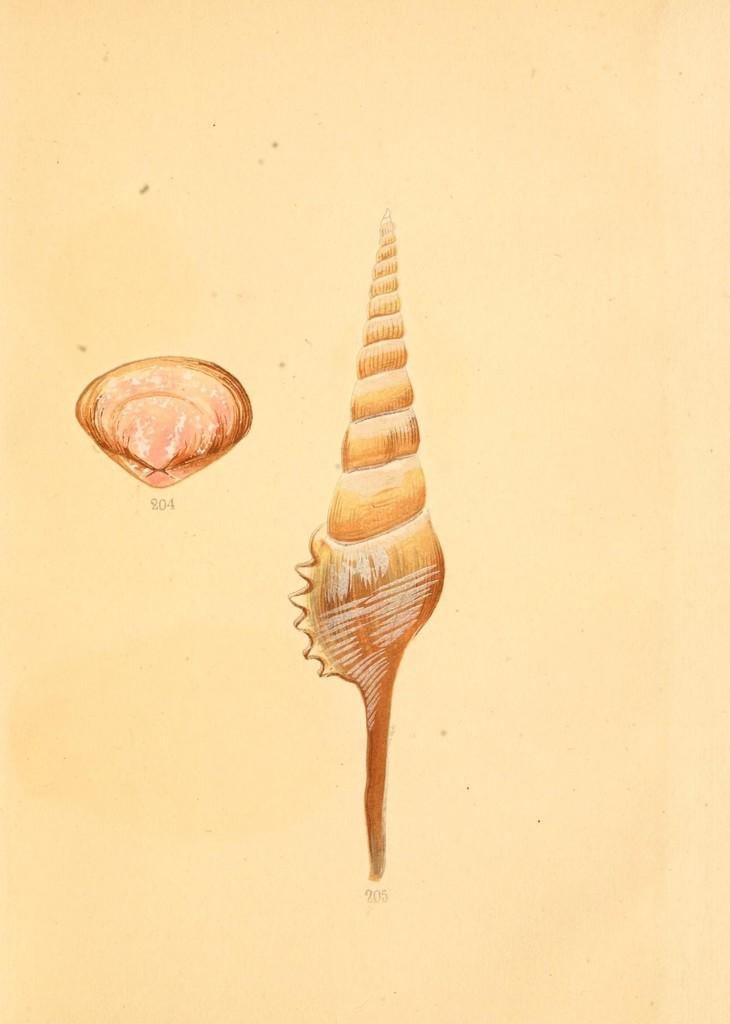Can you describe this image briefly? This picture is consists of a poster in the image. 